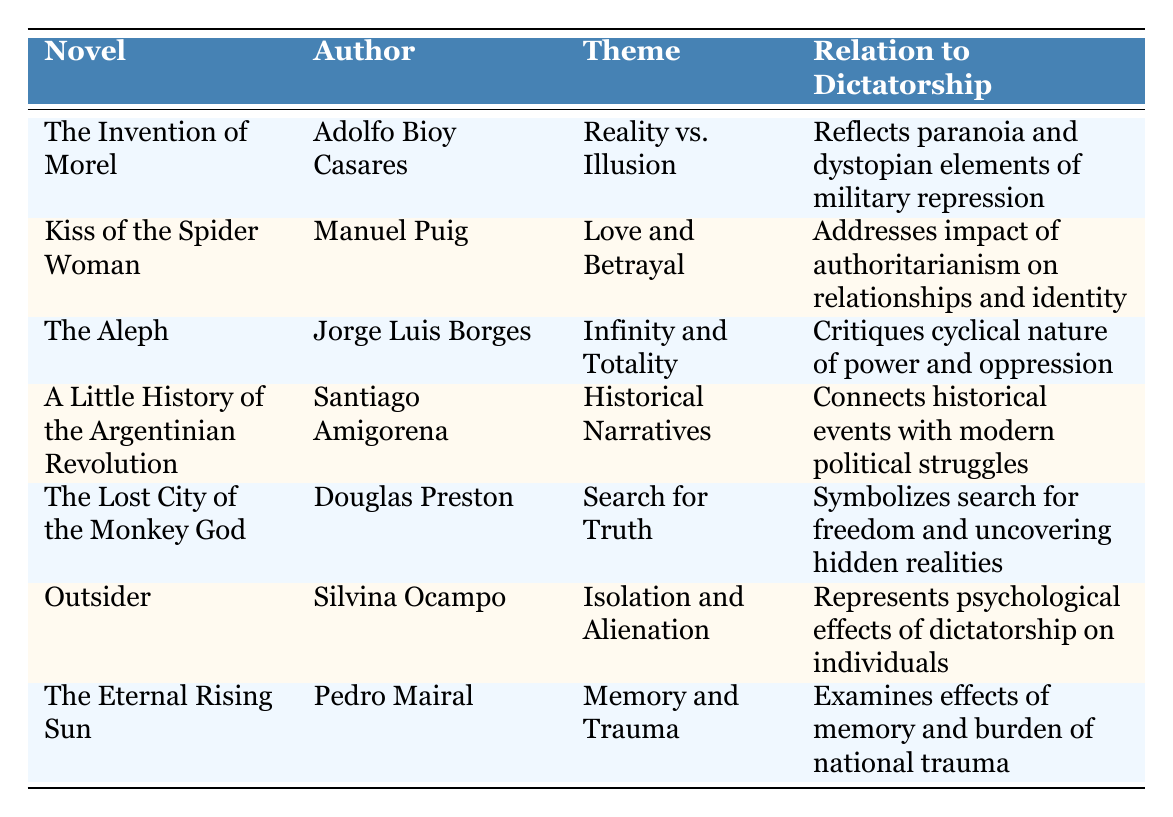What is the theme of "Kiss of the Spider Woman"? The table indicates that the theme of "Kiss of the Spider Woman" is "Love and Betrayal".
Answer: Love and Betrayal Who is the author of "The Eternal Rising Sun"? According to the table, the author of "The Eternal Rising Sun" is Pedro Mairal.
Answer: Pedro Mairal Which novel discusses "Memory and Trauma"? The table shows that "The Eternal Rising Sun" discusses "Memory and Trauma".
Answer: The Eternal Rising Sun What is the publication year of "The Invention of Morel"? The table lists "The Invention of Morel" as being published in 1940.
Answer: 1940 Is "The Aleph" related to critiques of power and oppression? Yes, the table states that "The Aleph" critiques the cyclical nature of power and oppression.
Answer: Yes How many novels were published before 1970? By checking the table, "The Invention of Morel" (1940), "The Aleph" (1945), and "Kiss of the Spider Woman" (1976) were published before 1970, which totals three novels.
Answer: 3 Which novel addresses the psychological effects of dictatorship on individuals? The table indicates that "Outsider" represents the psychological effects of dictatorship on individuals.
Answer: Outsider Do any novels in the table explicitly mention "the search for truth"? Yes, "The Lost City of the Monkey God" explicitly mentions "the search for truth".
Answer: Yes What themes do both "Outsider" and "Kiss of the Spider Woman" explore? The table shows "Outsider" focuses on "Isolation and Alienation," while "Kiss of the Spider Woman" explores "Love and Betrayal," indicating different types of human experiences under oppression.
Answer: Different themes Which novel connects historical events with modern political struggles? The table states that "A Little History of the Argentinian Revolution" connects historical events with modern political struggles.
Answer: A Little History of the Argentinian Revolution How does "The Invention of Morel" relate to military repression? The table explains that "The Invention of Morel" reflects paranoia and dystopian elements of military repression.
Answer: Reflects paranoia and dystopian elements 